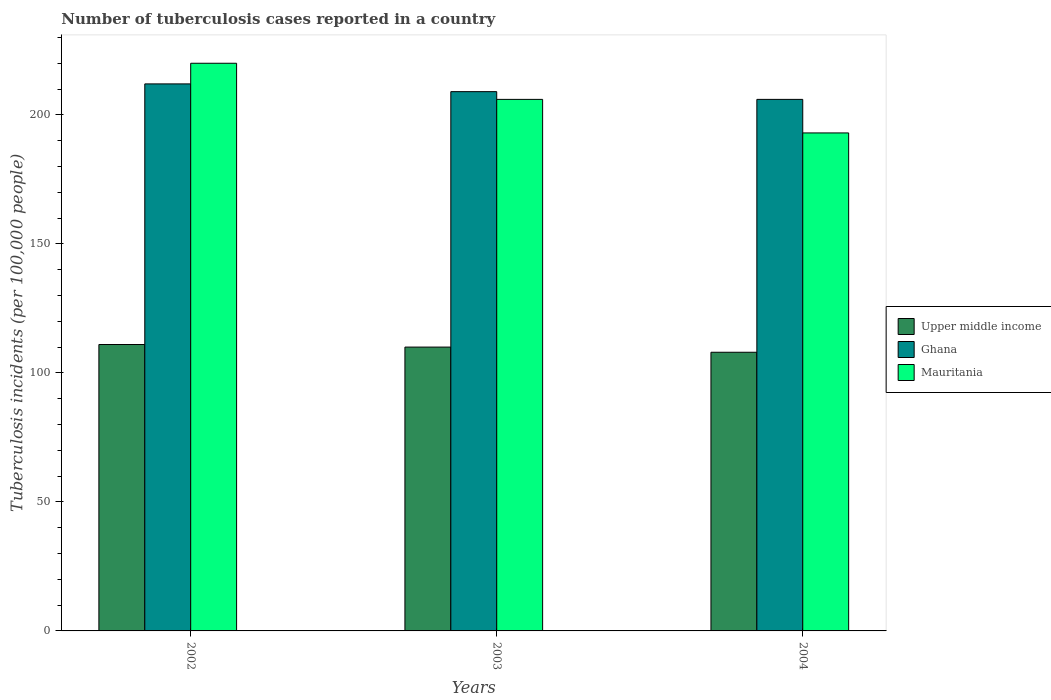Are the number of bars per tick equal to the number of legend labels?
Offer a very short reply. Yes. Are the number of bars on each tick of the X-axis equal?
Give a very brief answer. Yes. How many bars are there on the 1st tick from the left?
Your response must be concise. 3. What is the label of the 2nd group of bars from the left?
Give a very brief answer. 2003. In how many cases, is the number of bars for a given year not equal to the number of legend labels?
Ensure brevity in your answer.  0. What is the number of tuberculosis cases reported in in Upper middle income in 2004?
Provide a short and direct response. 108. Across all years, what is the maximum number of tuberculosis cases reported in in Ghana?
Provide a short and direct response. 212. Across all years, what is the minimum number of tuberculosis cases reported in in Ghana?
Keep it short and to the point. 206. What is the total number of tuberculosis cases reported in in Upper middle income in the graph?
Provide a short and direct response. 329. What is the difference between the number of tuberculosis cases reported in in Upper middle income in 2003 and that in 2004?
Give a very brief answer. 2. What is the difference between the number of tuberculosis cases reported in in Upper middle income in 2003 and the number of tuberculosis cases reported in in Ghana in 2002?
Ensure brevity in your answer.  -102. What is the average number of tuberculosis cases reported in in Upper middle income per year?
Make the answer very short. 109.67. In the year 2004, what is the difference between the number of tuberculosis cases reported in in Mauritania and number of tuberculosis cases reported in in Upper middle income?
Offer a terse response. 85. In how many years, is the number of tuberculosis cases reported in in Mauritania greater than 90?
Provide a succinct answer. 3. What is the ratio of the number of tuberculosis cases reported in in Mauritania in 2002 to that in 2003?
Keep it short and to the point. 1.07. Is the number of tuberculosis cases reported in in Upper middle income in 2002 less than that in 2004?
Offer a very short reply. No. What is the difference between the highest and the second highest number of tuberculosis cases reported in in Mauritania?
Your answer should be very brief. 14. What is the difference between the highest and the lowest number of tuberculosis cases reported in in Upper middle income?
Your answer should be compact. 3. In how many years, is the number of tuberculosis cases reported in in Upper middle income greater than the average number of tuberculosis cases reported in in Upper middle income taken over all years?
Your answer should be compact. 2. What does the 3rd bar from the left in 2002 represents?
Ensure brevity in your answer.  Mauritania. What does the 2nd bar from the right in 2003 represents?
Offer a terse response. Ghana. How many bars are there?
Provide a short and direct response. 9. How many years are there in the graph?
Make the answer very short. 3. What is the difference between two consecutive major ticks on the Y-axis?
Your answer should be very brief. 50. Are the values on the major ticks of Y-axis written in scientific E-notation?
Provide a short and direct response. No. Does the graph contain any zero values?
Make the answer very short. No. Does the graph contain grids?
Your response must be concise. No. How are the legend labels stacked?
Make the answer very short. Vertical. What is the title of the graph?
Keep it short and to the point. Number of tuberculosis cases reported in a country. Does "Serbia" appear as one of the legend labels in the graph?
Keep it short and to the point. No. What is the label or title of the X-axis?
Make the answer very short. Years. What is the label or title of the Y-axis?
Your answer should be compact. Tuberculosis incidents (per 100,0 people). What is the Tuberculosis incidents (per 100,000 people) of Upper middle income in 2002?
Ensure brevity in your answer.  111. What is the Tuberculosis incidents (per 100,000 people) in Ghana in 2002?
Your answer should be very brief. 212. What is the Tuberculosis incidents (per 100,000 people) of Mauritania in 2002?
Provide a succinct answer. 220. What is the Tuberculosis incidents (per 100,000 people) of Upper middle income in 2003?
Provide a succinct answer. 110. What is the Tuberculosis incidents (per 100,000 people) in Ghana in 2003?
Provide a short and direct response. 209. What is the Tuberculosis incidents (per 100,000 people) in Mauritania in 2003?
Offer a terse response. 206. What is the Tuberculosis incidents (per 100,000 people) in Upper middle income in 2004?
Your answer should be very brief. 108. What is the Tuberculosis incidents (per 100,000 people) in Ghana in 2004?
Make the answer very short. 206. What is the Tuberculosis incidents (per 100,000 people) in Mauritania in 2004?
Keep it short and to the point. 193. Across all years, what is the maximum Tuberculosis incidents (per 100,000 people) of Upper middle income?
Provide a short and direct response. 111. Across all years, what is the maximum Tuberculosis incidents (per 100,000 people) of Ghana?
Make the answer very short. 212. Across all years, what is the maximum Tuberculosis incidents (per 100,000 people) of Mauritania?
Your answer should be very brief. 220. Across all years, what is the minimum Tuberculosis incidents (per 100,000 people) in Upper middle income?
Keep it short and to the point. 108. Across all years, what is the minimum Tuberculosis incidents (per 100,000 people) of Ghana?
Your answer should be very brief. 206. Across all years, what is the minimum Tuberculosis incidents (per 100,000 people) of Mauritania?
Give a very brief answer. 193. What is the total Tuberculosis incidents (per 100,000 people) of Upper middle income in the graph?
Offer a terse response. 329. What is the total Tuberculosis incidents (per 100,000 people) in Ghana in the graph?
Provide a succinct answer. 627. What is the total Tuberculosis incidents (per 100,000 people) in Mauritania in the graph?
Your answer should be very brief. 619. What is the difference between the Tuberculosis incidents (per 100,000 people) of Upper middle income in 2002 and that in 2003?
Make the answer very short. 1. What is the difference between the Tuberculosis incidents (per 100,000 people) in Ghana in 2002 and that in 2003?
Give a very brief answer. 3. What is the difference between the Tuberculosis incidents (per 100,000 people) in Mauritania in 2002 and that in 2003?
Provide a short and direct response. 14. What is the difference between the Tuberculosis incidents (per 100,000 people) of Ghana in 2002 and that in 2004?
Offer a terse response. 6. What is the difference between the Tuberculosis incidents (per 100,000 people) in Mauritania in 2002 and that in 2004?
Offer a terse response. 27. What is the difference between the Tuberculosis incidents (per 100,000 people) of Upper middle income in 2002 and the Tuberculosis incidents (per 100,000 people) of Ghana in 2003?
Your response must be concise. -98. What is the difference between the Tuberculosis incidents (per 100,000 people) of Upper middle income in 2002 and the Tuberculosis incidents (per 100,000 people) of Mauritania in 2003?
Ensure brevity in your answer.  -95. What is the difference between the Tuberculosis incidents (per 100,000 people) in Ghana in 2002 and the Tuberculosis incidents (per 100,000 people) in Mauritania in 2003?
Keep it short and to the point. 6. What is the difference between the Tuberculosis incidents (per 100,000 people) of Upper middle income in 2002 and the Tuberculosis incidents (per 100,000 people) of Ghana in 2004?
Offer a terse response. -95. What is the difference between the Tuberculosis incidents (per 100,000 people) in Upper middle income in 2002 and the Tuberculosis incidents (per 100,000 people) in Mauritania in 2004?
Provide a succinct answer. -82. What is the difference between the Tuberculosis incidents (per 100,000 people) of Upper middle income in 2003 and the Tuberculosis incidents (per 100,000 people) of Ghana in 2004?
Offer a very short reply. -96. What is the difference between the Tuberculosis incidents (per 100,000 people) in Upper middle income in 2003 and the Tuberculosis incidents (per 100,000 people) in Mauritania in 2004?
Provide a succinct answer. -83. What is the average Tuberculosis incidents (per 100,000 people) in Upper middle income per year?
Give a very brief answer. 109.67. What is the average Tuberculosis incidents (per 100,000 people) of Ghana per year?
Offer a terse response. 209. What is the average Tuberculosis incidents (per 100,000 people) in Mauritania per year?
Offer a very short reply. 206.33. In the year 2002, what is the difference between the Tuberculosis incidents (per 100,000 people) of Upper middle income and Tuberculosis incidents (per 100,000 people) of Ghana?
Keep it short and to the point. -101. In the year 2002, what is the difference between the Tuberculosis incidents (per 100,000 people) in Upper middle income and Tuberculosis incidents (per 100,000 people) in Mauritania?
Give a very brief answer. -109. In the year 2002, what is the difference between the Tuberculosis incidents (per 100,000 people) in Ghana and Tuberculosis incidents (per 100,000 people) in Mauritania?
Keep it short and to the point. -8. In the year 2003, what is the difference between the Tuberculosis incidents (per 100,000 people) in Upper middle income and Tuberculosis incidents (per 100,000 people) in Ghana?
Make the answer very short. -99. In the year 2003, what is the difference between the Tuberculosis incidents (per 100,000 people) in Upper middle income and Tuberculosis incidents (per 100,000 people) in Mauritania?
Make the answer very short. -96. In the year 2003, what is the difference between the Tuberculosis incidents (per 100,000 people) of Ghana and Tuberculosis incidents (per 100,000 people) of Mauritania?
Provide a short and direct response. 3. In the year 2004, what is the difference between the Tuberculosis incidents (per 100,000 people) in Upper middle income and Tuberculosis incidents (per 100,000 people) in Ghana?
Your answer should be very brief. -98. In the year 2004, what is the difference between the Tuberculosis incidents (per 100,000 people) of Upper middle income and Tuberculosis incidents (per 100,000 people) of Mauritania?
Provide a short and direct response. -85. What is the ratio of the Tuberculosis incidents (per 100,000 people) in Upper middle income in 2002 to that in 2003?
Provide a succinct answer. 1.01. What is the ratio of the Tuberculosis incidents (per 100,000 people) of Ghana in 2002 to that in 2003?
Provide a short and direct response. 1.01. What is the ratio of the Tuberculosis incidents (per 100,000 people) of Mauritania in 2002 to that in 2003?
Provide a succinct answer. 1.07. What is the ratio of the Tuberculosis incidents (per 100,000 people) of Upper middle income in 2002 to that in 2004?
Make the answer very short. 1.03. What is the ratio of the Tuberculosis incidents (per 100,000 people) of Ghana in 2002 to that in 2004?
Provide a short and direct response. 1.03. What is the ratio of the Tuberculosis incidents (per 100,000 people) of Mauritania in 2002 to that in 2004?
Your response must be concise. 1.14. What is the ratio of the Tuberculosis incidents (per 100,000 people) of Upper middle income in 2003 to that in 2004?
Offer a terse response. 1.02. What is the ratio of the Tuberculosis incidents (per 100,000 people) of Ghana in 2003 to that in 2004?
Offer a terse response. 1.01. What is the ratio of the Tuberculosis incidents (per 100,000 people) in Mauritania in 2003 to that in 2004?
Your response must be concise. 1.07. What is the difference between the highest and the second highest Tuberculosis incidents (per 100,000 people) of Mauritania?
Offer a very short reply. 14. What is the difference between the highest and the lowest Tuberculosis incidents (per 100,000 people) in Ghana?
Give a very brief answer. 6. What is the difference between the highest and the lowest Tuberculosis incidents (per 100,000 people) in Mauritania?
Offer a very short reply. 27. 